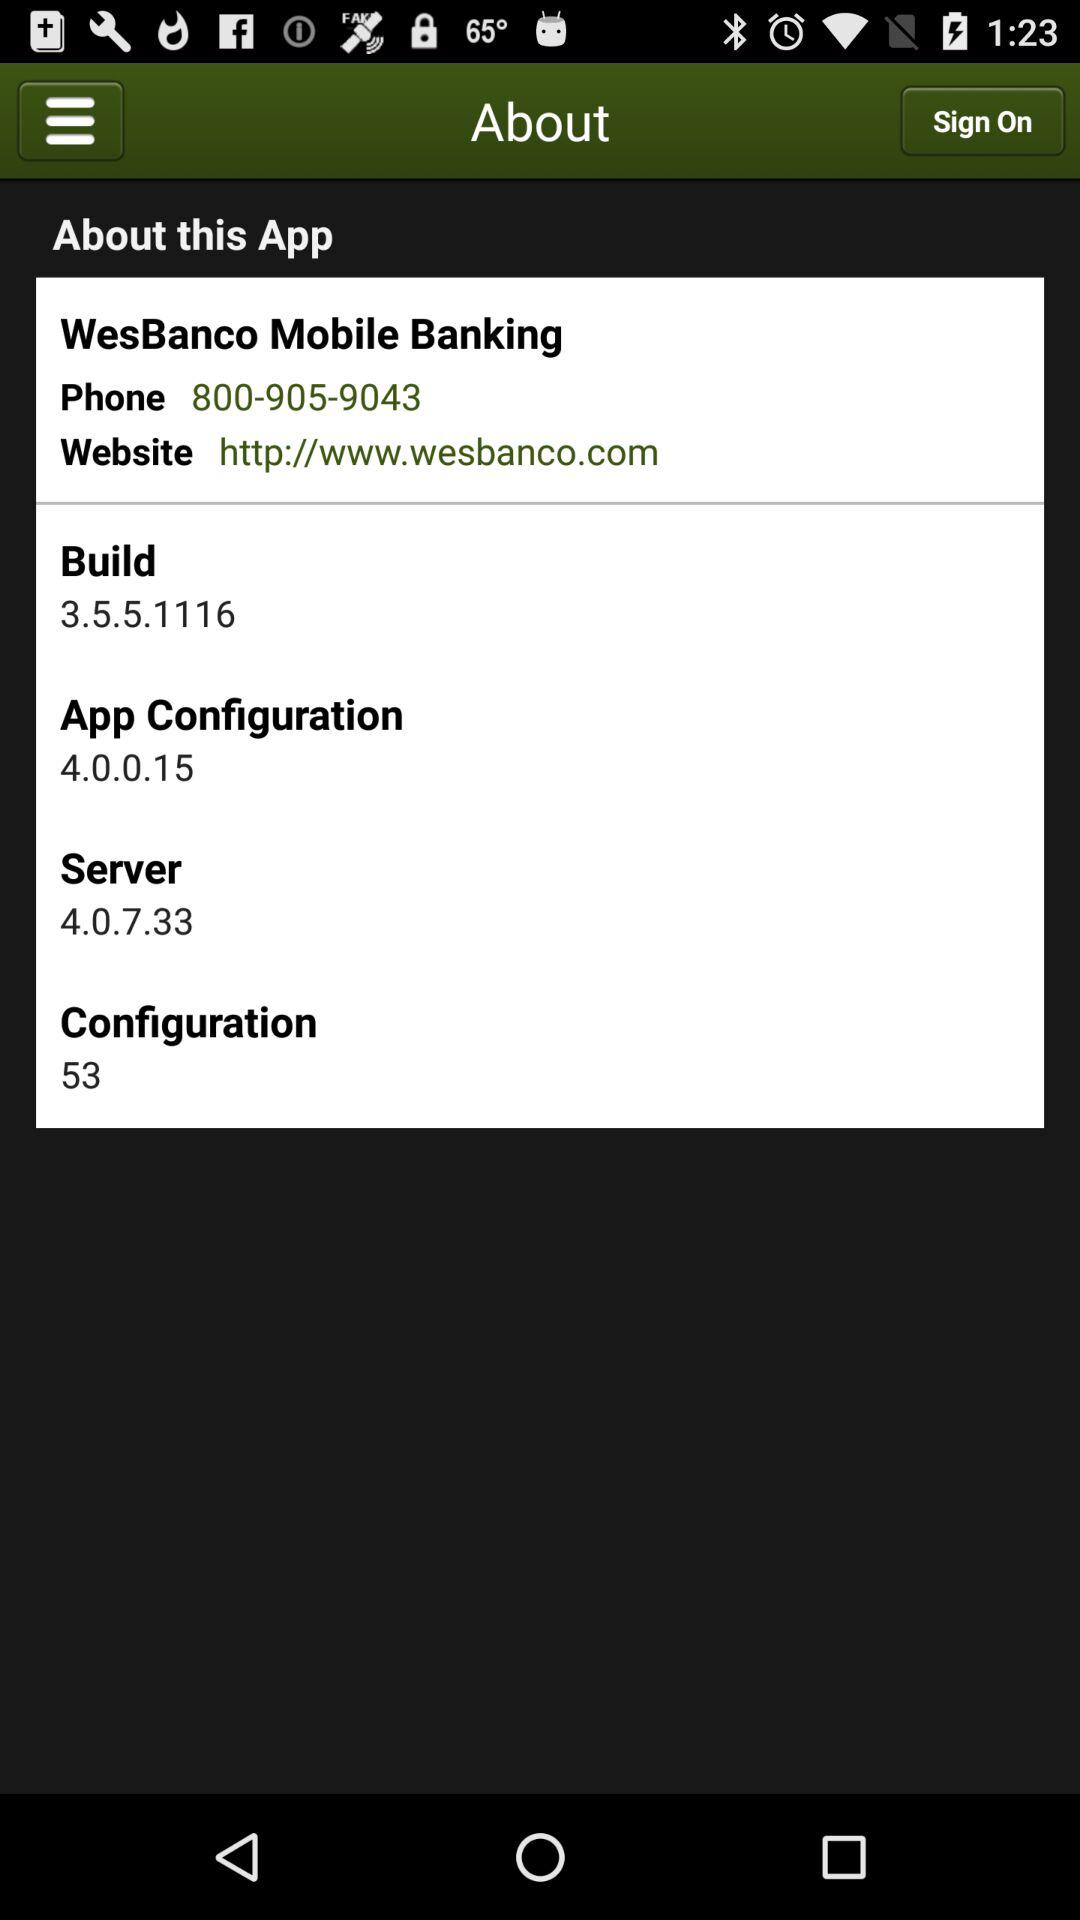How many configurations are there? There are 53 configurations. 